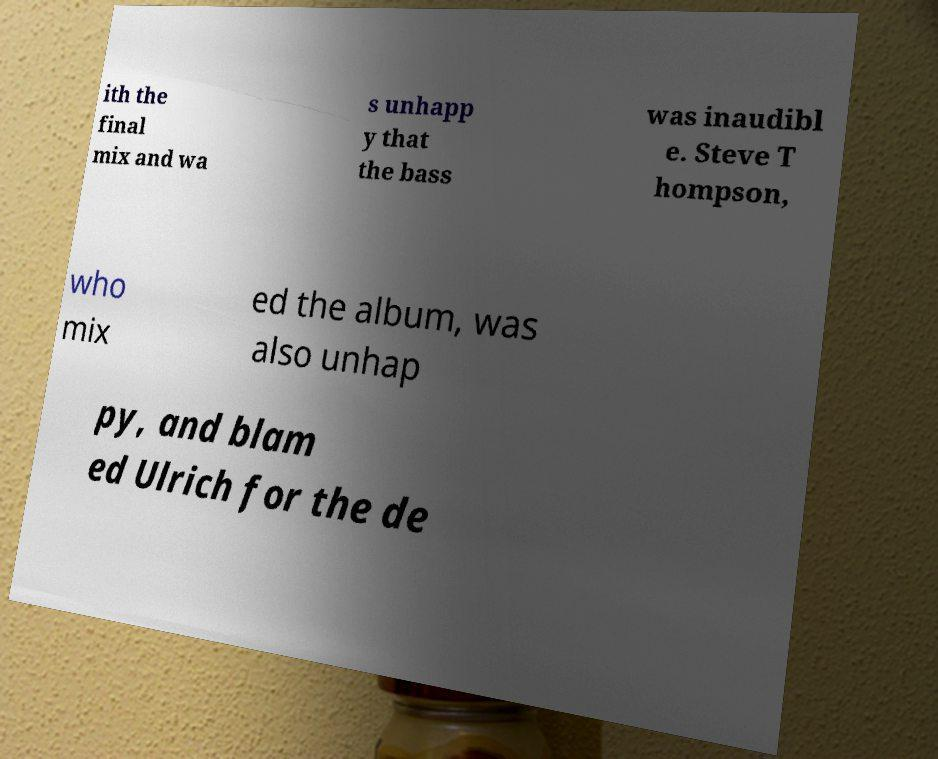I need the written content from this picture converted into text. Can you do that? ith the final mix and wa s unhapp y that the bass was inaudibl e. Steve T hompson, who mix ed the album, was also unhap py, and blam ed Ulrich for the de 